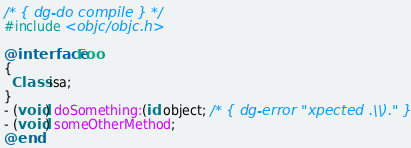Convert code to text. <code><loc_0><loc_0><loc_500><loc_500><_ObjectiveC_>/* { dg-do compile } */
#include <objc/objc.h>

@interface Foo
{
  Class isa;
}
- (void) doSomething:(id object; /* { dg-error "xpected .\\)." } */
- (void) someOtherMethod;
@end
</code> 